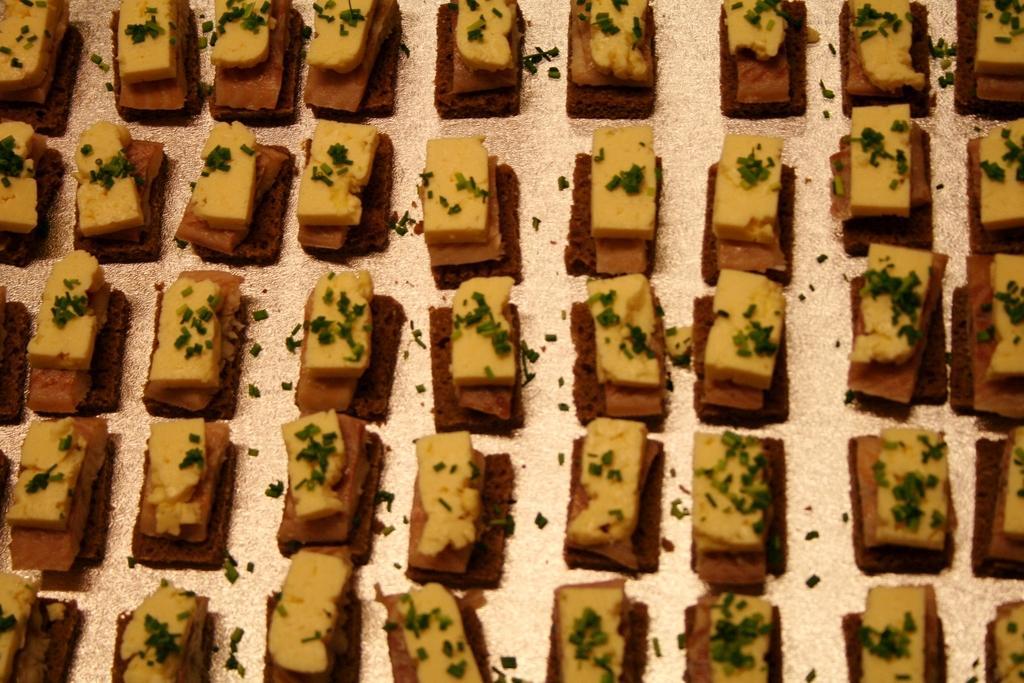In one or two sentences, can you explain what this image depicts? In this image we can see some food items and it looks like the cakes. 